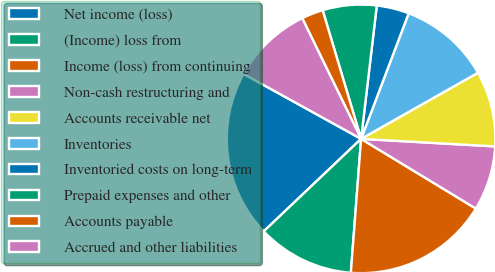<chart> <loc_0><loc_0><loc_500><loc_500><pie_chart><fcel>Net income (loss)<fcel>(Income) loss from<fcel>Income (loss) from continuing<fcel>Non-cash restructuring and<fcel>Accounts receivable net<fcel>Inventories<fcel>Inventoried costs on long-term<fcel>Prepaid expenses and other<fcel>Accounts payable<fcel>Accrued and other liabilities<nl><fcel>20.13%<fcel>11.69%<fcel>17.53%<fcel>7.79%<fcel>9.09%<fcel>11.04%<fcel>3.9%<fcel>6.49%<fcel>2.6%<fcel>9.74%<nl></chart> 